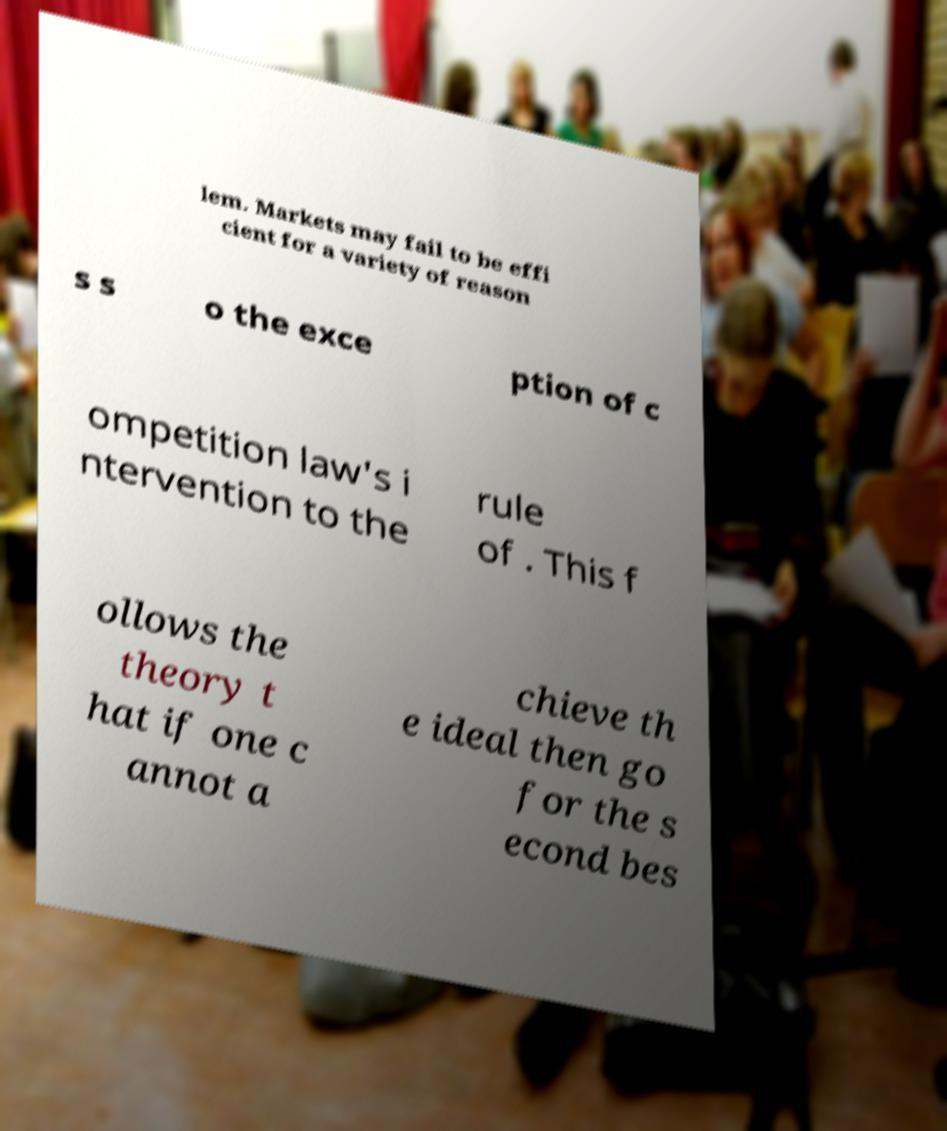Could you extract and type out the text from this image? lem. Markets may fail to be effi cient for a variety of reason s s o the exce ption of c ompetition law's i ntervention to the rule of . This f ollows the theory t hat if one c annot a chieve th e ideal then go for the s econd bes 